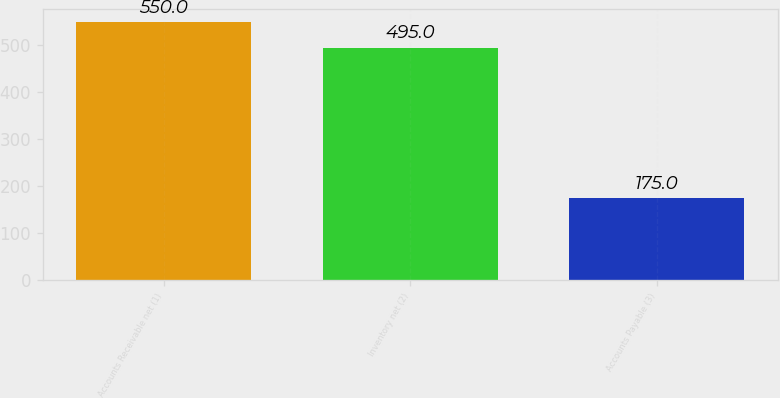Convert chart to OTSL. <chart><loc_0><loc_0><loc_500><loc_500><bar_chart><fcel>Accounts Receivable net (1)<fcel>Inventory net (2)<fcel>Accounts Payable (3)<nl><fcel>550<fcel>495<fcel>175<nl></chart> 